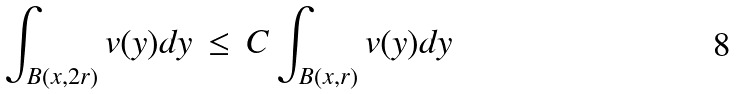Convert formula to latex. <formula><loc_0><loc_0><loc_500><loc_500>\int _ { B ( x , 2 r ) } v ( y ) d y \, \leq \, C \int _ { B ( x , r ) } v ( y ) d y</formula> 